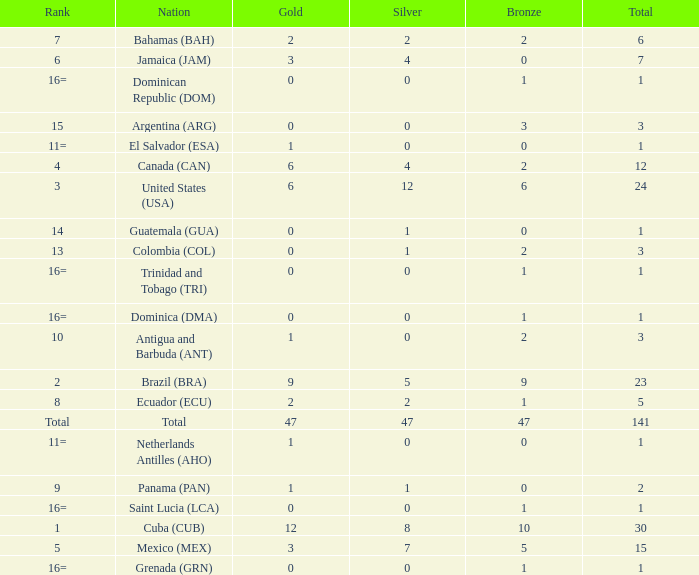How many bronzes have a Nation of jamaica (jam), and a Total smaller than 7? 0.0. 